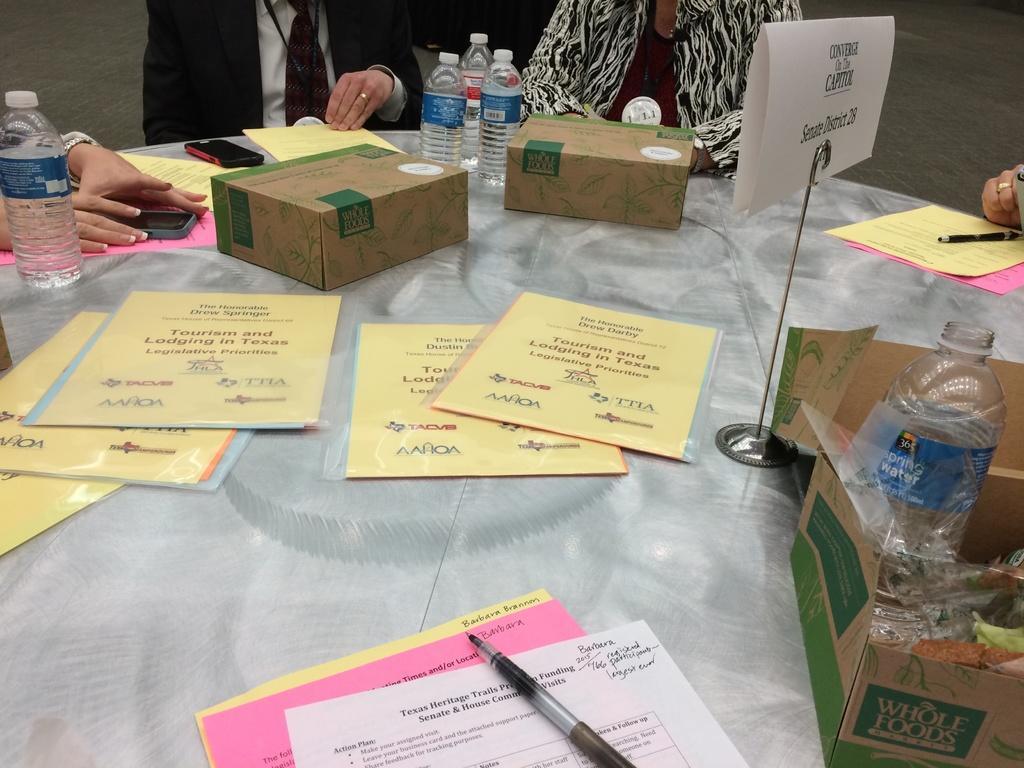In one or two sentences, can you explain what this image depicts? As we can see in the image there are four persons sitting on chairs and there is a table over here. On table there are papers, pen, box, bottle and a mobile phone. 